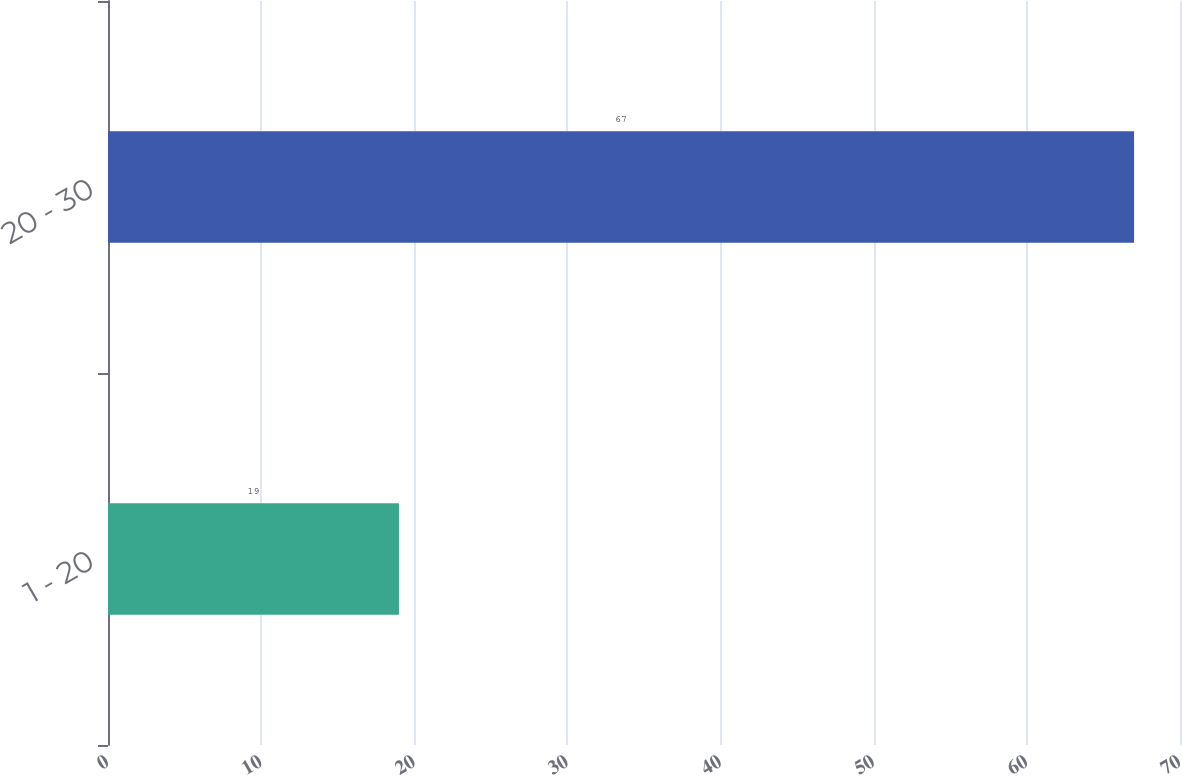Convert chart to OTSL. <chart><loc_0><loc_0><loc_500><loc_500><bar_chart><fcel>1 - 20<fcel>20 - 30<nl><fcel>19<fcel>67<nl></chart> 